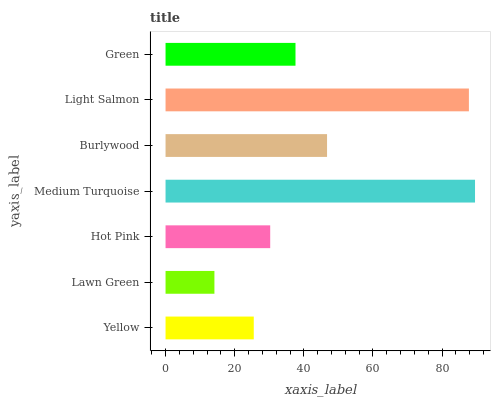Is Lawn Green the minimum?
Answer yes or no. Yes. Is Medium Turquoise the maximum?
Answer yes or no. Yes. Is Hot Pink the minimum?
Answer yes or no. No. Is Hot Pink the maximum?
Answer yes or no. No. Is Hot Pink greater than Lawn Green?
Answer yes or no. Yes. Is Lawn Green less than Hot Pink?
Answer yes or no. Yes. Is Lawn Green greater than Hot Pink?
Answer yes or no. No. Is Hot Pink less than Lawn Green?
Answer yes or no. No. Is Green the high median?
Answer yes or no. Yes. Is Green the low median?
Answer yes or no. Yes. Is Burlywood the high median?
Answer yes or no. No. Is Burlywood the low median?
Answer yes or no. No. 